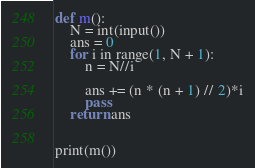Convert code to text. <code><loc_0><loc_0><loc_500><loc_500><_Python_>def m():
    N = int(input())
    ans = 0
    for i in range(1, N + 1):
        n = N//i

        ans += (n * (n + 1) // 2)*i
        pass
    return ans


print(m())
</code> 